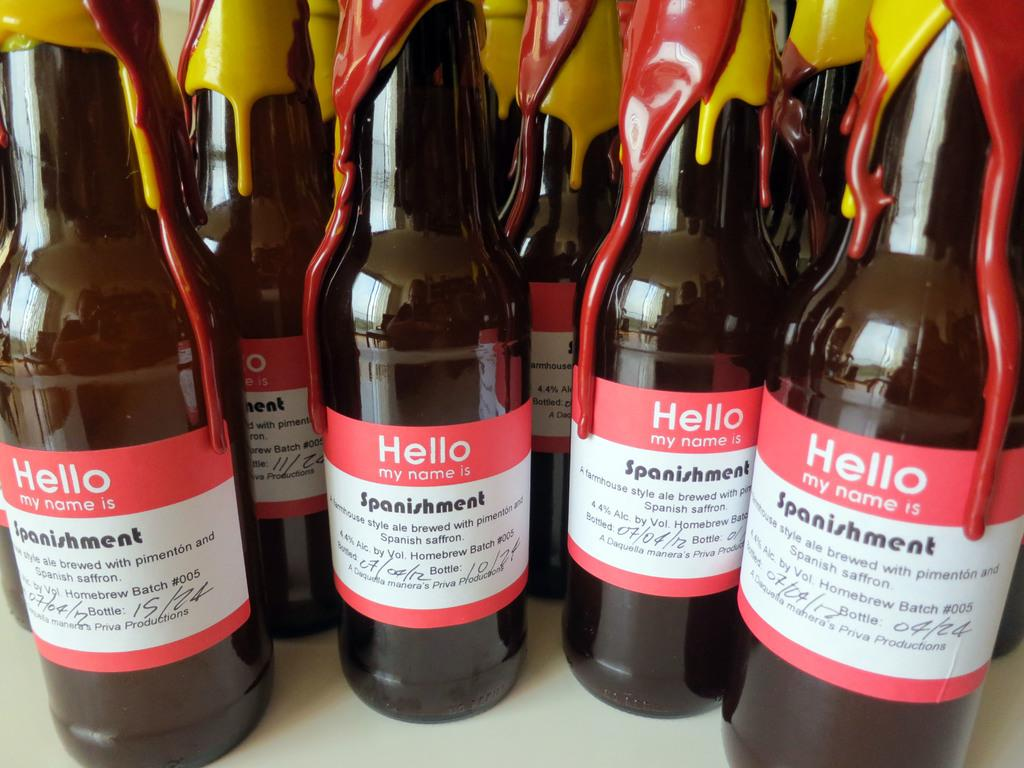<image>
Write a terse but informative summary of the picture. A group of beer bottle have the tag of Hello my name is labels. 